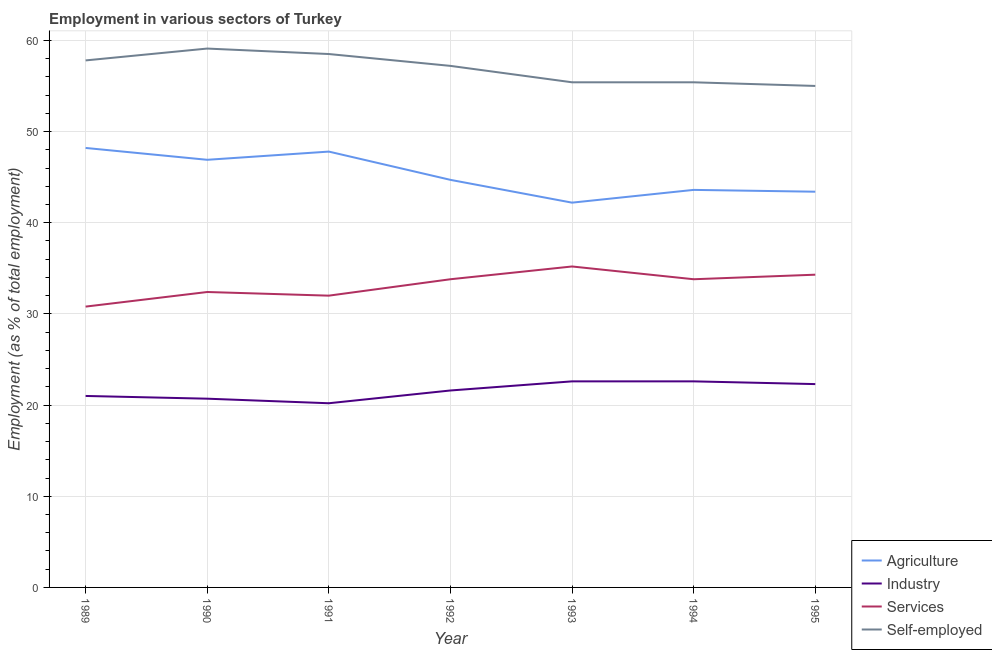How many different coloured lines are there?
Provide a short and direct response. 4. What is the percentage of workers in industry in 1990?
Your answer should be compact. 20.7. Across all years, what is the maximum percentage of workers in services?
Give a very brief answer. 35.2. Across all years, what is the minimum percentage of workers in industry?
Your answer should be compact. 20.2. What is the total percentage of workers in industry in the graph?
Your answer should be very brief. 151. What is the difference between the percentage of workers in industry in 1989 and that in 1993?
Keep it short and to the point. -1.6. What is the difference between the percentage of self employed workers in 1993 and the percentage of workers in agriculture in 1991?
Make the answer very short. 7.6. What is the average percentage of workers in services per year?
Make the answer very short. 33.19. In the year 1990, what is the difference between the percentage of self employed workers and percentage of workers in industry?
Ensure brevity in your answer.  38.4. What is the ratio of the percentage of self employed workers in 1992 to that in 1993?
Keep it short and to the point. 1.03. Is the percentage of self employed workers in 1993 less than that in 1994?
Make the answer very short. No. What is the difference between the highest and the second highest percentage of workers in agriculture?
Provide a succinct answer. 0.4. What is the difference between the highest and the lowest percentage of self employed workers?
Offer a very short reply. 4.1. In how many years, is the percentage of self employed workers greater than the average percentage of self employed workers taken over all years?
Offer a terse response. 4. Is the percentage of self employed workers strictly greater than the percentage of workers in industry over the years?
Provide a succinct answer. Yes. Is the percentage of workers in agriculture strictly less than the percentage of workers in services over the years?
Make the answer very short. No. How many years are there in the graph?
Your response must be concise. 7. Are the values on the major ticks of Y-axis written in scientific E-notation?
Offer a terse response. No. Where does the legend appear in the graph?
Make the answer very short. Bottom right. How are the legend labels stacked?
Your response must be concise. Vertical. What is the title of the graph?
Provide a succinct answer. Employment in various sectors of Turkey. Does "Plant species" appear as one of the legend labels in the graph?
Offer a very short reply. No. What is the label or title of the Y-axis?
Provide a short and direct response. Employment (as % of total employment). What is the Employment (as % of total employment) in Agriculture in 1989?
Keep it short and to the point. 48.2. What is the Employment (as % of total employment) of Services in 1989?
Offer a very short reply. 30.8. What is the Employment (as % of total employment) of Self-employed in 1989?
Keep it short and to the point. 57.8. What is the Employment (as % of total employment) in Agriculture in 1990?
Provide a short and direct response. 46.9. What is the Employment (as % of total employment) of Industry in 1990?
Ensure brevity in your answer.  20.7. What is the Employment (as % of total employment) of Services in 1990?
Your response must be concise. 32.4. What is the Employment (as % of total employment) in Self-employed in 1990?
Give a very brief answer. 59.1. What is the Employment (as % of total employment) in Agriculture in 1991?
Make the answer very short. 47.8. What is the Employment (as % of total employment) of Industry in 1991?
Your response must be concise. 20.2. What is the Employment (as % of total employment) in Services in 1991?
Keep it short and to the point. 32. What is the Employment (as % of total employment) in Self-employed in 1991?
Your answer should be very brief. 58.5. What is the Employment (as % of total employment) in Agriculture in 1992?
Offer a terse response. 44.7. What is the Employment (as % of total employment) in Industry in 1992?
Keep it short and to the point. 21.6. What is the Employment (as % of total employment) of Services in 1992?
Your answer should be compact. 33.8. What is the Employment (as % of total employment) of Self-employed in 1992?
Your answer should be very brief. 57.2. What is the Employment (as % of total employment) of Agriculture in 1993?
Make the answer very short. 42.2. What is the Employment (as % of total employment) of Industry in 1993?
Provide a succinct answer. 22.6. What is the Employment (as % of total employment) of Services in 1993?
Ensure brevity in your answer.  35.2. What is the Employment (as % of total employment) of Self-employed in 1993?
Your answer should be very brief. 55.4. What is the Employment (as % of total employment) of Agriculture in 1994?
Provide a short and direct response. 43.6. What is the Employment (as % of total employment) of Industry in 1994?
Offer a very short reply. 22.6. What is the Employment (as % of total employment) of Services in 1994?
Keep it short and to the point. 33.8. What is the Employment (as % of total employment) in Self-employed in 1994?
Keep it short and to the point. 55.4. What is the Employment (as % of total employment) of Agriculture in 1995?
Provide a succinct answer. 43.4. What is the Employment (as % of total employment) in Industry in 1995?
Your answer should be very brief. 22.3. What is the Employment (as % of total employment) in Services in 1995?
Keep it short and to the point. 34.3. What is the Employment (as % of total employment) in Self-employed in 1995?
Make the answer very short. 55. Across all years, what is the maximum Employment (as % of total employment) of Agriculture?
Offer a terse response. 48.2. Across all years, what is the maximum Employment (as % of total employment) in Industry?
Keep it short and to the point. 22.6. Across all years, what is the maximum Employment (as % of total employment) of Services?
Your answer should be compact. 35.2. Across all years, what is the maximum Employment (as % of total employment) of Self-employed?
Provide a short and direct response. 59.1. Across all years, what is the minimum Employment (as % of total employment) in Agriculture?
Provide a short and direct response. 42.2. Across all years, what is the minimum Employment (as % of total employment) in Industry?
Keep it short and to the point. 20.2. Across all years, what is the minimum Employment (as % of total employment) of Services?
Provide a succinct answer. 30.8. Across all years, what is the minimum Employment (as % of total employment) of Self-employed?
Keep it short and to the point. 55. What is the total Employment (as % of total employment) of Agriculture in the graph?
Ensure brevity in your answer.  316.8. What is the total Employment (as % of total employment) of Industry in the graph?
Your answer should be compact. 151. What is the total Employment (as % of total employment) of Services in the graph?
Provide a succinct answer. 232.3. What is the total Employment (as % of total employment) in Self-employed in the graph?
Offer a terse response. 398.4. What is the difference between the Employment (as % of total employment) in Services in 1989 and that in 1990?
Offer a terse response. -1.6. What is the difference between the Employment (as % of total employment) of Self-employed in 1989 and that in 1990?
Provide a succinct answer. -1.3. What is the difference between the Employment (as % of total employment) of Self-employed in 1989 and that in 1991?
Make the answer very short. -0.7. What is the difference between the Employment (as % of total employment) in Services in 1989 and that in 1992?
Provide a succinct answer. -3. What is the difference between the Employment (as % of total employment) of Self-employed in 1989 and that in 1992?
Your answer should be very brief. 0.6. What is the difference between the Employment (as % of total employment) of Agriculture in 1989 and that in 1993?
Provide a succinct answer. 6. What is the difference between the Employment (as % of total employment) in Industry in 1989 and that in 1993?
Your answer should be very brief. -1.6. What is the difference between the Employment (as % of total employment) in Agriculture in 1989 and that in 1994?
Your answer should be compact. 4.6. What is the difference between the Employment (as % of total employment) in Self-employed in 1989 and that in 1994?
Your response must be concise. 2.4. What is the difference between the Employment (as % of total employment) in Industry in 1989 and that in 1995?
Your answer should be very brief. -1.3. What is the difference between the Employment (as % of total employment) of Self-employed in 1989 and that in 1995?
Give a very brief answer. 2.8. What is the difference between the Employment (as % of total employment) in Self-employed in 1990 and that in 1991?
Offer a terse response. 0.6. What is the difference between the Employment (as % of total employment) in Industry in 1990 and that in 1992?
Provide a succinct answer. -0.9. What is the difference between the Employment (as % of total employment) in Self-employed in 1990 and that in 1992?
Provide a succinct answer. 1.9. What is the difference between the Employment (as % of total employment) of Agriculture in 1990 and that in 1994?
Offer a terse response. 3.3. What is the difference between the Employment (as % of total employment) in Services in 1990 and that in 1994?
Keep it short and to the point. -1.4. What is the difference between the Employment (as % of total employment) in Industry in 1990 and that in 1995?
Provide a succinct answer. -1.6. What is the difference between the Employment (as % of total employment) in Agriculture in 1991 and that in 1992?
Your response must be concise. 3.1. What is the difference between the Employment (as % of total employment) of Services in 1991 and that in 1992?
Your answer should be very brief. -1.8. What is the difference between the Employment (as % of total employment) in Self-employed in 1991 and that in 1992?
Ensure brevity in your answer.  1.3. What is the difference between the Employment (as % of total employment) in Services in 1991 and that in 1993?
Provide a succinct answer. -3.2. What is the difference between the Employment (as % of total employment) in Agriculture in 1991 and that in 1994?
Provide a succinct answer. 4.2. What is the difference between the Employment (as % of total employment) of Industry in 1991 and that in 1994?
Offer a very short reply. -2.4. What is the difference between the Employment (as % of total employment) of Services in 1991 and that in 1994?
Offer a very short reply. -1.8. What is the difference between the Employment (as % of total employment) in Agriculture in 1991 and that in 1995?
Make the answer very short. 4.4. What is the difference between the Employment (as % of total employment) of Industry in 1991 and that in 1995?
Ensure brevity in your answer.  -2.1. What is the difference between the Employment (as % of total employment) of Industry in 1992 and that in 1993?
Give a very brief answer. -1. What is the difference between the Employment (as % of total employment) in Agriculture in 1992 and that in 1994?
Ensure brevity in your answer.  1.1. What is the difference between the Employment (as % of total employment) in Industry in 1992 and that in 1994?
Keep it short and to the point. -1. What is the difference between the Employment (as % of total employment) of Self-employed in 1992 and that in 1994?
Your response must be concise. 1.8. What is the difference between the Employment (as % of total employment) in Agriculture in 1992 and that in 1995?
Give a very brief answer. 1.3. What is the difference between the Employment (as % of total employment) of Industry in 1992 and that in 1995?
Your answer should be very brief. -0.7. What is the difference between the Employment (as % of total employment) of Agriculture in 1993 and that in 1994?
Offer a very short reply. -1.4. What is the difference between the Employment (as % of total employment) of Industry in 1993 and that in 1994?
Make the answer very short. 0. What is the difference between the Employment (as % of total employment) in Services in 1993 and that in 1995?
Offer a terse response. 0.9. What is the difference between the Employment (as % of total employment) of Agriculture in 1994 and that in 1995?
Your answer should be compact. 0.2. What is the difference between the Employment (as % of total employment) of Services in 1994 and that in 1995?
Offer a very short reply. -0.5. What is the difference between the Employment (as % of total employment) of Industry in 1989 and the Employment (as % of total employment) of Self-employed in 1990?
Give a very brief answer. -38.1. What is the difference between the Employment (as % of total employment) of Services in 1989 and the Employment (as % of total employment) of Self-employed in 1990?
Keep it short and to the point. -28.3. What is the difference between the Employment (as % of total employment) in Agriculture in 1989 and the Employment (as % of total employment) in Industry in 1991?
Make the answer very short. 28. What is the difference between the Employment (as % of total employment) of Agriculture in 1989 and the Employment (as % of total employment) of Services in 1991?
Your response must be concise. 16.2. What is the difference between the Employment (as % of total employment) in Agriculture in 1989 and the Employment (as % of total employment) in Self-employed in 1991?
Your answer should be compact. -10.3. What is the difference between the Employment (as % of total employment) of Industry in 1989 and the Employment (as % of total employment) of Services in 1991?
Offer a terse response. -11. What is the difference between the Employment (as % of total employment) in Industry in 1989 and the Employment (as % of total employment) in Self-employed in 1991?
Make the answer very short. -37.5. What is the difference between the Employment (as % of total employment) in Services in 1989 and the Employment (as % of total employment) in Self-employed in 1991?
Provide a short and direct response. -27.7. What is the difference between the Employment (as % of total employment) of Agriculture in 1989 and the Employment (as % of total employment) of Industry in 1992?
Make the answer very short. 26.6. What is the difference between the Employment (as % of total employment) in Agriculture in 1989 and the Employment (as % of total employment) in Services in 1992?
Keep it short and to the point. 14.4. What is the difference between the Employment (as % of total employment) in Agriculture in 1989 and the Employment (as % of total employment) in Self-employed in 1992?
Provide a short and direct response. -9. What is the difference between the Employment (as % of total employment) in Industry in 1989 and the Employment (as % of total employment) in Self-employed in 1992?
Your answer should be compact. -36.2. What is the difference between the Employment (as % of total employment) in Services in 1989 and the Employment (as % of total employment) in Self-employed in 1992?
Ensure brevity in your answer.  -26.4. What is the difference between the Employment (as % of total employment) in Agriculture in 1989 and the Employment (as % of total employment) in Industry in 1993?
Offer a very short reply. 25.6. What is the difference between the Employment (as % of total employment) of Industry in 1989 and the Employment (as % of total employment) of Self-employed in 1993?
Provide a succinct answer. -34.4. What is the difference between the Employment (as % of total employment) of Services in 1989 and the Employment (as % of total employment) of Self-employed in 1993?
Provide a short and direct response. -24.6. What is the difference between the Employment (as % of total employment) in Agriculture in 1989 and the Employment (as % of total employment) in Industry in 1994?
Offer a terse response. 25.6. What is the difference between the Employment (as % of total employment) in Agriculture in 1989 and the Employment (as % of total employment) in Services in 1994?
Offer a terse response. 14.4. What is the difference between the Employment (as % of total employment) in Industry in 1989 and the Employment (as % of total employment) in Services in 1994?
Provide a short and direct response. -12.8. What is the difference between the Employment (as % of total employment) of Industry in 1989 and the Employment (as % of total employment) of Self-employed in 1994?
Provide a succinct answer. -34.4. What is the difference between the Employment (as % of total employment) of Services in 1989 and the Employment (as % of total employment) of Self-employed in 1994?
Keep it short and to the point. -24.6. What is the difference between the Employment (as % of total employment) in Agriculture in 1989 and the Employment (as % of total employment) in Industry in 1995?
Ensure brevity in your answer.  25.9. What is the difference between the Employment (as % of total employment) in Agriculture in 1989 and the Employment (as % of total employment) in Services in 1995?
Make the answer very short. 13.9. What is the difference between the Employment (as % of total employment) in Agriculture in 1989 and the Employment (as % of total employment) in Self-employed in 1995?
Offer a very short reply. -6.8. What is the difference between the Employment (as % of total employment) of Industry in 1989 and the Employment (as % of total employment) of Services in 1995?
Ensure brevity in your answer.  -13.3. What is the difference between the Employment (as % of total employment) in Industry in 1989 and the Employment (as % of total employment) in Self-employed in 1995?
Your answer should be very brief. -34. What is the difference between the Employment (as % of total employment) of Services in 1989 and the Employment (as % of total employment) of Self-employed in 1995?
Keep it short and to the point. -24.2. What is the difference between the Employment (as % of total employment) of Agriculture in 1990 and the Employment (as % of total employment) of Industry in 1991?
Keep it short and to the point. 26.7. What is the difference between the Employment (as % of total employment) in Industry in 1990 and the Employment (as % of total employment) in Self-employed in 1991?
Offer a very short reply. -37.8. What is the difference between the Employment (as % of total employment) of Services in 1990 and the Employment (as % of total employment) of Self-employed in 1991?
Keep it short and to the point. -26.1. What is the difference between the Employment (as % of total employment) in Agriculture in 1990 and the Employment (as % of total employment) in Industry in 1992?
Provide a short and direct response. 25.3. What is the difference between the Employment (as % of total employment) in Agriculture in 1990 and the Employment (as % of total employment) in Self-employed in 1992?
Provide a short and direct response. -10.3. What is the difference between the Employment (as % of total employment) in Industry in 1990 and the Employment (as % of total employment) in Self-employed in 1992?
Make the answer very short. -36.5. What is the difference between the Employment (as % of total employment) of Services in 1990 and the Employment (as % of total employment) of Self-employed in 1992?
Provide a short and direct response. -24.8. What is the difference between the Employment (as % of total employment) of Agriculture in 1990 and the Employment (as % of total employment) of Industry in 1993?
Give a very brief answer. 24.3. What is the difference between the Employment (as % of total employment) in Agriculture in 1990 and the Employment (as % of total employment) in Services in 1993?
Provide a short and direct response. 11.7. What is the difference between the Employment (as % of total employment) in Agriculture in 1990 and the Employment (as % of total employment) in Self-employed in 1993?
Make the answer very short. -8.5. What is the difference between the Employment (as % of total employment) of Industry in 1990 and the Employment (as % of total employment) of Self-employed in 1993?
Your answer should be very brief. -34.7. What is the difference between the Employment (as % of total employment) of Services in 1990 and the Employment (as % of total employment) of Self-employed in 1993?
Your answer should be very brief. -23. What is the difference between the Employment (as % of total employment) of Agriculture in 1990 and the Employment (as % of total employment) of Industry in 1994?
Your response must be concise. 24.3. What is the difference between the Employment (as % of total employment) in Agriculture in 1990 and the Employment (as % of total employment) in Services in 1994?
Your answer should be very brief. 13.1. What is the difference between the Employment (as % of total employment) of Industry in 1990 and the Employment (as % of total employment) of Self-employed in 1994?
Offer a very short reply. -34.7. What is the difference between the Employment (as % of total employment) in Services in 1990 and the Employment (as % of total employment) in Self-employed in 1994?
Provide a succinct answer. -23. What is the difference between the Employment (as % of total employment) of Agriculture in 1990 and the Employment (as % of total employment) of Industry in 1995?
Your answer should be very brief. 24.6. What is the difference between the Employment (as % of total employment) in Agriculture in 1990 and the Employment (as % of total employment) in Services in 1995?
Offer a very short reply. 12.6. What is the difference between the Employment (as % of total employment) in Agriculture in 1990 and the Employment (as % of total employment) in Self-employed in 1995?
Ensure brevity in your answer.  -8.1. What is the difference between the Employment (as % of total employment) of Industry in 1990 and the Employment (as % of total employment) of Services in 1995?
Your answer should be very brief. -13.6. What is the difference between the Employment (as % of total employment) of Industry in 1990 and the Employment (as % of total employment) of Self-employed in 1995?
Your response must be concise. -34.3. What is the difference between the Employment (as % of total employment) in Services in 1990 and the Employment (as % of total employment) in Self-employed in 1995?
Provide a short and direct response. -22.6. What is the difference between the Employment (as % of total employment) of Agriculture in 1991 and the Employment (as % of total employment) of Industry in 1992?
Offer a very short reply. 26.2. What is the difference between the Employment (as % of total employment) in Industry in 1991 and the Employment (as % of total employment) in Services in 1992?
Offer a very short reply. -13.6. What is the difference between the Employment (as % of total employment) in Industry in 1991 and the Employment (as % of total employment) in Self-employed in 1992?
Give a very brief answer. -37. What is the difference between the Employment (as % of total employment) in Services in 1991 and the Employment (as % of total employment) in Self-employed in 1992?
Your answer should be compact. -25.2. What is the difference between the Employment (as % of total employment) of Agriculture in 1991 and the Employment (as % of total employment) of Industry in 1993?
Provide a succinct answer. 25.2. What is the difference between the Employment (as % of total employment) of Agriculture in 1991 and the Employment (as % of total employment) of Self-employed in 1993?
Make the answer very short. -7.6. What is the difference between the Employment (as % of total employment) of Industry in 1991 and the Employment (as % of total employment) of Services in 1993?
Your response must be concise. -15. What is the difference between the Employment (as % of total employment) of Industry in 1991 and the Employment (as % of total employment) of Self-employed in 1993?
Provide a short and direct response. -35.2. What is the difference between the Employment (as % of total employment) in Services in 1991 and the Employment (as % of total employment) in Self-employed in 1993?
Make the answer very short. -23.4. What is the difference between the Employment (as % of total employment) in Agriculture in 1991 and the Employment (as % of total employment) in Industry in 1994?
Your answer should be compact. 25.2. What is the difference between the Employment (as % of total employment) in Industry in 1991 and the Employment (as % of total employment) in Services in 1994?
Give a very brief answer. -13.6. What is the difference between the Employment (as % of total employment) of Industry in 1991 and the Employment (as % of total employment) of Self-employed in 1994?
Provide a short and direct response. -35.2. What is the difference between the Employment (as % of total employment) of Services in 1991 and the Employment (as % of total employment) of Self-employed in 1994?
Your response must be concise. -23.4. What is the difference between the Employment (as % of total employment) in Agriculture in 1991 and the Employment (as % of total employment) in Services in 1995?
Keep it short and to the point. 13.5. What is the difference between the Employment (as % of total employment) in Industry in 1991 and the Employment (as % of total employment) in Services in 1995?
Keep it short and to the point. -14.1. What is the difference between the Employment (as % of total employment) of Industry in 1991 and the Employment (as % of total employment) of Self-employed in 1995?
Offer a terse response. -34.8. What is the difference between the Employment (as % of total employment) of Agriculture in 1992 and the Employment (as % of total employment) of Industry in 1993?
Make the answer very short. 22.1. What is the difference between the Employment (as % of total employment) of Agriculture in 1992 and the Employment (as % of total employment) of Services in 1993?
Your answer should be compact. 9.5. What is the difference between the Employment (as % of total employment) of Industry in 1992 and the Employment (as % of total employment) of Self-employed in 1993?
Ensure brevity in your answer.  -33.8. What is the difference between the Employment (as % of total employment) in Services in 1992 and the Employment (as % of total employment) in Self-employed in 1993?
Your answer should be compact. -21.6. What is the difference between the Employment (as % of total employment) in Agriculture in 1992 and the Employment (as % of total employment) in Industry in 1994?
Ensure brevity in your answer.  22.1. What is the difference between the Employment (as % of total employment) in Agriculture in 1992 and the Employment (as % of total employment) in Services in 1994?
Your response must be concise. 10.9. What is the difference between the Employment (as % of total employment) in Agriculture in 1992 and the Employment (as % of total employment) in Self-employed in 1994?
Your answer should be compact. -10.7. What is the difference between the Employment (as % of total employment) of Industry in 1992 and the Employment (as % of total employment) of Self-employed in 1994?
Make the answer very short. -33.8. What is the difference between the Employment (as % of total employment) of Services in 1992 and the Employment (as % of total employment) of Self-employed in 1994?
Your response must be concise. -21.6. What is the difference between the Employment (as % of total employment) of Agriculture in 1992 and the Employment (as % of total employment) of Industry in 1995?
Provide a short and direct response. 22.4. What is the difference between the Employment (as % of total employment) in Agriculture in 1992 and the Employment (as % of total employment) in Services in 1995?
Your answer should be very brief. 10.4. What is the difference between the Employment (as % of total employment) in Agriculture in 1992 and the Employment (as % of total employment) in Self-employed in 1995?
Give a very brief answer. -10.3. What is the difference between the Employment (as % of total employment) in Industry in 1992 and the Employment (as % of total employment) in Self-employed in 1995?
Provide a succinct answer. -33.4. What is the difference between the Employment (as % of total employment) of Services in 1992 and the Employment (as % of total employment) of Self-employed in 1995?
Keep it short and to the point. -21.2. What is the difference between the Employment (as % of total employment) of Agriculture in 1993 and the Employment (as % of total employment) of Industry in 1994?
Your answer should be very brief. 19.6. What is the difference between the Employment (as % of total employment) of Industry in 1993 and the Employment (as % of total employment) of Services in 1994?
Your answer should be compact. -11.2. What is the difference between the Employment (as % of total employment) of Industry in 1993 and the Employment (as % of total employment) of Self-employed in 1994?
Offer a very short reply. -32.8. What is the difference between the Employment (as % of total employment) in Services in 1993 and the Employment (as % of total employment) in Self-employed in 1994?
Ensure brevity in your answer.  -20.2. What is the difference between the Employment (as % of total employment) of Agriculture in 1993 and the Employment (as % of total employment) of Industry in 1995?
Your answer should be compact. 19.9. What is the difference between the Employment (as % of total employment) of Industry in 1993 and the Employment (as % of total employment) of Self-employed in 1995?
Keep it short and to the point. -32.4. What is the difference between the Employment (as % of total employment) in Services in 1993 and the Employment (as % of total employment) in Self-employed in 1995?
Your answer should be compact. -19.8. What is the difference between the Employment (as % of total employment) in Agriculture in 1994 and the Employment (as % of total employment) in Industry in 1995?
Give a very brief answer. 21.3. What is the difference between the Employment (as % of total employment) in Agriculture in 1994 and the Employment (as % of total employment) in Services in 1995?
Ensure brevity in your answer.  9.3. What is the difference between the Employment (as % of total employment) in Agriculture in 1994 and the Employment (as % of total employment) in Self-employed in 1995?
Your response must be concise. -11.4. What is the difference between the Employment (as % of total employment) of Industry in 1994 and the Employment (as % of total employment) of Services in 1995?
Give a very brief answer. -11.7. What is the difference between the Employment (as % of total employment) of Industry in 1994 and the Employment (as % of total employment) of Self-employed in 1995?
Provide a short and direct response. -32.4. What is the difference between the Employment (as % of total employment) in Services in 1994 and the Employment (as % of total employment) in Self-employed in 1995?
Offer a terse response. -21.2. What is the average Employment (as % of total employment) in Agriculture per year?
Make the answer very short. 45.26. What is the average Employment (as % of total employment) in Industry per year?
Ensure brevity in your answer.  21.57. What is the average Employment (as % of total employment) in Services per year?
Offer a terse response. 33.19. What is the average Employment (as % of total employment) in Self-employed per year?
Offer a very short reply. 56.91. In the year 1989, what is the difference between the Employment (as % of total employment) in Agriculture and Employment (as % of total employment) in Industry?
Your answer should be compact. 27.2. In the year 1989, what is the difference between the Employment (as % of total employment) of Industry and Employment (as % of total employment) of Self-employed?
Ensure brevity in your answer.  -36.8. In the year 1989, what is the difference between the Employment (as % of total employment) of Services and Employment (as % of total employment) of Self-employed?
Provide a succinct answer. -27. In the year 1990, what is the difference between the Employment (as % of total employment) of Agriculture and Employment (as % of total employment) of Industry?
Keep it short and to the point. 26.2. In the year 1990, what is the difference between the Employment (as % of total employment) in Agriculture and Employment (as % of total employment) in Services?
Your answer should be very brief. 14.5. In the year 1990, what is the difference between the Employment (as % of total employment) of Industry and Employment (as % of total employment) of Self-employed?
Give a very brief answer. -38.4. In the year 1990, what is the difference between the Employment (as % of total employment) in Services and Employment (as % of total employment) in Self-employed?
Ensure brevity in your answer.  -26.7. In the year 1991, what is the difference between the Employment (as % of total employment) of Agriculture and Employment (as % of total employment) of Industry?
Your response must be concise. 27.6. In the year 1991, what is the difference between the Employment (as % of total employment) in Agriculture and Employment (as % of total employment) in Services?
Offer a terse response. 15.8. In the year 1991, what is the difference between the Employment (as % of total employment) in Industry and Employment (as % of total employment) in Services?
Your answer should be very brief. -11.8. In the year 1991, what is the difference between the Employment (as % of total employment) in Industry and Employment (as % of total employment) in Self-employed?
Your response must be concise. -38.3. In the year 1991, what is the difference between the Employment (as % of total employment) in Services and Employment (as % of total employment) in Self-employed?
Your response must be concise. -26.5. In the year 1992, what is the difference between the Employment (as % of total employment) in Agriculture and Employment (as % of total employment) in Industry?
Your answer should be compact. 23.1. In the year 1992, what is the difference between the Employment (as % of total employment) of Agriculture and Employment (as % of total employment) of Services?
Give a very brief answer. 10.9. In the year 1992, what is the difference between the Employment (as % of total employment) in Industry and Employment (as % of total employment) in Services?
Your answer should be compact. -12.2. In the year 1992, what is the difference between the Employment (as % of total employment) in Industry and Employment (as % of total employment) in Self-employed?
Provide a short and direct response. -35.6. In the year 1992, what is the difference between the Employment (as % of total employment) in Services and Employment (as % of total employment) in Self-employed?
Your response must be concise. -23.4. In the year 1993, what is the difference between the Employment (as % of total employment) in Agriculture and Employment (as % of total employment) in Industry?
Your answer should be compact. 19.6. In the year 1993, what is the difference between the Employment (as % of total employment) of Agriculture and Employment (as % of total employment) of Services?
Your answer should be compact. 7. In the year 1993, what is the difference between the Employment (as % of total employment) in Industry and Employment (as % of total employment) in Services?
Offer a very short reply. -12.6. In the year 1993, what is the difference between the Employment (as % of total employment) in Industry and Employment (as % of total employment) in Self-employed?
Offer a very short reply. -32.8. In the year 1993, what is the difference between the Employment (as % of total employment) of Services and Employment (as % of total employment) of Self-employed?
Give a very brief answer. -20.2. In the year 1994, what is the difference between the Employment (as % of total employment) in Industry and Employment (as % of total employment) in Self-employed?
Make the answer very short. -32.8. In the year 1994, what is the difference between the Employment (as % of total employment) of Services and Employment (as % of total employment) of Self-employed?
Keep it short and to the point. -21.6. In the year 1995, what is the difference between the Employment (as % of total employment) in Agriculture and Employment (as % of total employment) in Industry?
Make the answer very short. 21.1. In the year 1995, what is the difference between the Employment (as % of total employment) in Agriculture and Employment (as % of total employment) in Self-employed?
Ensure brevity in your answer.  -11.6. In the year 1995, what is the difference between the Employment (as % of total employment) in Industry and Employment (as % of total employment) in Self-employed?
Offer a very short reply. -32.7. In the year 1995, what is the difference between the Employment (as % of total employment) in Services and Employment (as % of total employment) in Self-employed?
Ensure brevity in your answer.  -20.7. What is the ratio of the Employment (as % of total employment) of Agriculture in 1989 to that in 1990?
Ensure brevity in your answer.  1.03. What is the ratio of the Employment (as % of total employment) in Industry in 1989 to that in 1990?
Make the answer very short. 1.01. What is the ratio of the Employment (as % of total employment) of Services in 1989 to that in 1990?
Ensure brevity in your answer.  0.95. What is the ratio of the Employment (as % of total employment) in Self-employed in 1989 to that in 1990?
Your answer should be compact. 0.98. What is the ratio of the Employment (as % of total employment) of Agriculture in 1989 to that in 1991?
Provide a short and direct response. 1.01. What is the ratio of the Employment (as % of total employment) in Industry in 1989 to that in 1991?
Your answer should be compact. 1.04. What is the ratio of the Employment (as % of total employment) in Services in 1989 to that in 1991?
Make the answer very short. 0.96. What is the ratio of the Employment (as % of total employment) in Agriculture in 1989 to that in 1992?
Keep it short and to the point. 1.08. What is the ratio of the Employment (as % of total employment) in Industry in 1989 to that in 1992?
Provide a succinct answer. 0.97. What is the ratio of the Employment (as % of total employment) of Services in 1989 to that in 1992?
Ensure brevity in your answer.  0.91. What is the ratio of the Employment (as % of total employment) in Self-employed in 1989 to that in 1992?
Keep it short and to the point. 1.01. What is the ratio of the Employment (as % of total employment) in Agriculture in 1989 to that in 1993?
Offer a very short reply. 1.14. What is the ratio of the Employment (as % of total employment) of Industry in 1989 to that in 1993?
Provide a succinct answer. 0.93. What is the ratio of the Employment (as % of total employment) of Services in 1989 to that in 1993?
Offer a very short reply. 0.88. What is the ratio of the Employment (as % of total employment) in Self-employed in 1989 to that in 1993?
Your answer should be very brief. 1.04. What is the ratio of the Employment (as % of total employment) of Agriculture in 1989 to that in 1994?
Ensure brevity in your answer.  1.11. What is the ratio of the Employment (as % of total employment) in Industry in 1989 to that in 1994?
Provide a short and direct response. 0.93. What is the ratio of the Employment (as % of total employment) of Services in 1989 to that in 1994?
Offer a very short reply. 0.91. What is the ratio of the Employment (as % of total employment) of Self-employed in 1989 to that in 1994?
Your answer should be very brief. 1.04. What is the ratio of the Employment (as % of total employment) of Agriculture in 1989 to that in 1995?
Keep it short and to the point. 1.11. What is the ratio of the Employment (as % of total employment) in Industry in 1989 to that in 1995?
Your answer should be very brief. 0.94. What is the ratio of the Employment (as % of total employment) of Services in 1989 to that in 1995?
Give a very brief answer. 0.9. What is the ratio of the Employment (as % of total employment) of Self-employed in 1989 to that in 1995?
Make the answer very short. 1.05. What is the ratio of the Employment (as % of total employment) of Agriculture in 1990 to that in 1991?
Your answer should be very brief. 0.98. What is the ratio of the Employment (as % of total employment) in Industry in 1990 to that in 1991?
Keep it short and to the point. 1.02. What is the ratio of the Employment (as % of total employment) in Services in 1990 to that in 1991?
Your answer should be very brief. 1.01. What is the ratio of the Employment (as % of total employment) in Self-employed in 1990 to that in 1991?
Make the answer very short. 1.01. What is the ratio of the Employment (as % of total employment) of Agriculture in 1990 to that in 1992?
Keep it short and to the point. 1.05. What is the ratio of the Employment (as % of total employment) of Services in 1990 to that in 1992?
Offer a terse response. 0.96. What is the ratio of the Employment (as % of total employment) of Self-employed in 1990 to that in 1992?
Keep it short and to the point. 1.03. What is the ratio of the Employment (as % of total employment) in Agriculture in 1990 to that in 1993?
Offer a terse response. 1.11. What is the ratio of the Employment (as % of total employment) in Industry in 1990 to that in 1993?
Provide a succinct answer. 0.92. What is the ratio of the Employment (as % of total employment) of Services in 1990 to that in 1993?
Provide a succinct answer. 0.92. What is the ratio of the Employment (as % of total employment) of Self-employed in 1990 to that in 1993?
Keep it short and to the point. 1.07. What is the ratio of the Employment (as % of total employment) of Agriculture in 1990 to that in 1994?
Make the answer very short. 1.08. What is the ratio of the Employment (as % of total employment) in Industry in 1990 to that in 1994?
Offer a terse response. 0.92. What is the ratio of the Employment (as % of total employment) of Services in 1990 to that in 1994?
Your response must be concise. 0.96. What is the ratio of the Employment (as % of total employment) of Self-employed in 1990 to that in 1994?
Ensure brevity in your answer.  1.07. What is the ratio of the Employment (as % of total employment) of Agriculture in 1990 to that in 1995?
Ensure brevity in your answer.  1.08. What is the ratio of the Employment (as % of total employment) of Industry in 1990 to that in 1995?
Offer a very short reply. 0.93. What is the ratio of the Employment (as % of total employment) of Services in 1990 to that in 1995?
Offer a very short reply. 0.94. What is the ratio of the Employment (as % of total employment) of Self-employed in 1990 to that in 1995?
Ensure brevity in your answer.  1.07. What is the ratio of the Employment (as % of total employment) in Agriculture in 1991 to that in 1992?
Ensure brevity in your answer.  1.07. What is the ratio of the Employment (as % of total employment) of Industry in 1991 to that in 1992?
Keep it short and to the point. 0.94. What is the ratio of the Employment (as % of total employment) in Services in 1991 to that in 1992?
Offer a very short reply. 0.95. What is the ratio of the Employment (as % of total employment) in Self-employed in 1991 to that in 1992?
Your answer should be compact. 1.02. What is the ratio of the Employment (as % of total employment) of Agriculture in 1991 to that in 1993?
Offer a terse response. 1.13. What is the ratio of the Employment (as % of total employment) in Industry in 1991 to that in 1993?
Provide a succinct answer. 0.89. What is the ratio of the Employment (as % of total employment) of Self-employed in 1991 to that in 1993?
Your answer should be very brief. 1.06. What is the ratio of the Employment (as % of total employment) in Agriculture in 1991 to that in 1994?
Ensure brevity in your answer.  1.1. What is the ratio of the Employment (as % of total employment) in Industry in 1991 to that in 1994?
Offer a very short reply. 0.89. What is the ratio of the Employment (as % of total employment) in Services in 1991 to that in 1994?
Keep it short and to the point. 0.95. What is the ratio of the Employment (as % of total employment) in Self-employed in 1991 to that in 1994?
Your response must be concise. 1.06. What is the ratio of the Employment (as % of total employment) in Agriculture in 1991 to that in 1995?
Make the answer very short. 1.1. What is the ratio of the Employment (as % of total employment) of Industry in 1991 to that in 1995?
Your answer should be compact. 0.91. What is the ratio of the Employment (as % of total employment) in Services in 1991 to that in 1995?
Provide a short and direct response. 0.93. What is the ratio of the Employment (as % of total employment) of Self-employed in 1991 to that in 1995?
Your answer should be compact. 1.06. What is the ratio of the Employment (as % of total employment) in Agriculture in 1992 to that in 1993?
Your answer should be very brief. 1.06. What is the ratio of the Employment (as % of total employment) of Industry in 1992 to that in 1993?
Offer a very short reply. 0.96. What is the ratio of the Employment (as % of total employment) in Services in 1992 to that in 1993?
Provide a succinct answer. 0.96. What is the ratio of the Employment (as % of total employment) in Self-employed in 1992 to that in 1993?
Offer a very short reply. 1.03. What is the ratio of the Employment (as % of total employment) in Agriculture in 1992 to that in 1994?
Give a very brief answer. 1.03. What is the ratio of the Employment (as % of total employment) in Industry in 1992 to that in 1994?
Offer a very short reply. 0.96. What is the ratio of the Employment (as % of total employment) of Services in 1992 to that in 1994?
Make the answer very short. 1. What is the ratio of the Employment (as % of total employment) of Self-employed in 1992 to that in 1994?
Keep it short and to the point. 1.03. What is the ratio of the Employment (as % of total employment) of Agriculture in 1992 to that in 1995?
Your response must be concise. 1.03. What is the ratio of the Employment (as % of total employment) of Industry in 1992 to that in 1995?
Your answer should be compact. 0.97. What is the ratio of the Employment (as % of total employment) of Services in 1992 to that in 1995?
Your answer should be compact. 0.99. What is the ratio of the Employment (as % of total employment) of Self-employed in 1992 to that in 1995?
Your answer should be compact. 1.04. What is the ratio of the Employment (as % of total employment) of Agriculture in 1993 to that in 1994?
Your response must be concise. 0.97. What is the ratio of the Employment (as % of total employment) of Services in 1993 to that in 1994?
Give a very brief answer. 1.04. What is the ratio of the Employment (as % of total employment) in Agriculture in 1993 to that in 1995?
Your answer should be compact. 0.97. What is the ratio of the Employment (as % of total employment) in Industry in 1993 to that in 1995?
Ensure brevity in your answer.  1.01. What is the ratio of the Employment (as % of total employment) in Services in 1993 to that in 1995?
Offer a terse response. 1.03. What is the ratio of the Employment (as % of total employment) in Self-employed in 1993 to that in 1995?
Your answer should be compact. 1.01. What is the ratio of the Employment (as % of total employment) in Industry in 1994 to that in 1995?
Give a very brief answer. 1.01. What is the ratio of the Employment (as % of total employment) of Services in 1994 to that in 1995?
Your answer should be compact. 0.99. What is the ratio of the Employment (as % of total employment) in Self-employed in 1994 to that in 1995?
Make the answer very short. 1.01. What is the difference between the highest and the second highest Employment (as % of total employment) of Agriculture?
Keep it short and to the point. 0.4. What is the difference between the highest and the second highest Employment (as % of total employment) in Industry?
Make the answer very short. 0. What is the difference between the highest and the second highest Employment (as % of total employment) of Services?
Your answer should be compact. 0.9. What is the difference between the highest and the lowest Employment (as % of total employment) in Agriculture?
Ensure brevity in your answer.  6. What is the difference between the highest and the lowest Employment (as % of total employment) of Industry?
Make the answer very short. 2.4. What is the difference between the highest and the lowest Employment (as % of total employment) in Services?
Offer a terse response. 4.4. 